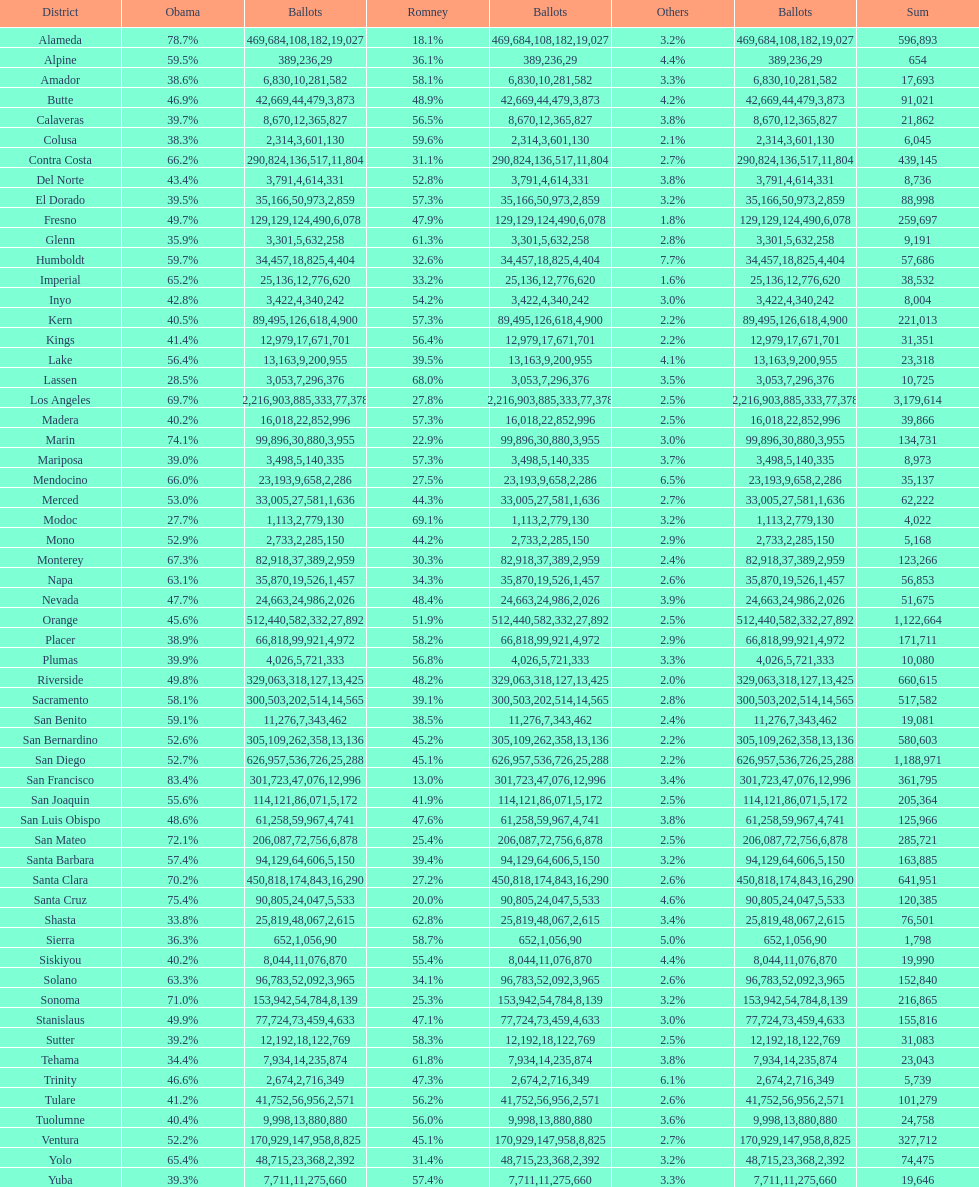Did romney earn more or less votes than obama did in alameda county? Less. 